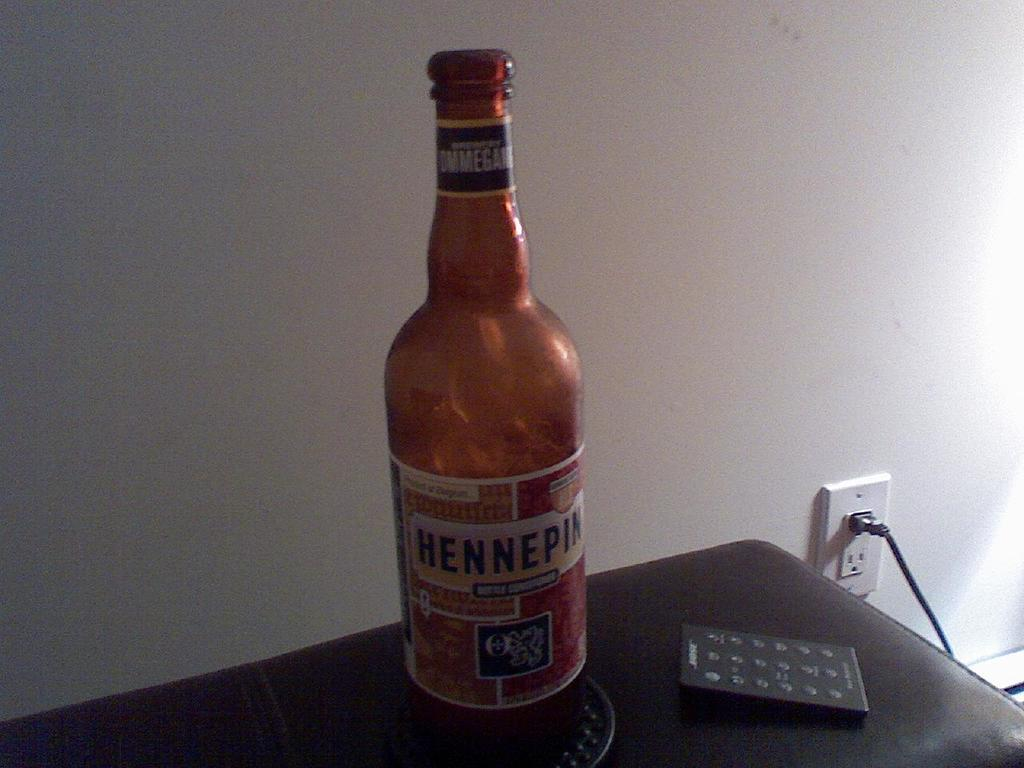<image>
Provide a brief description of the given image. A large bottle sitting on a cupholder is called hennepin. 